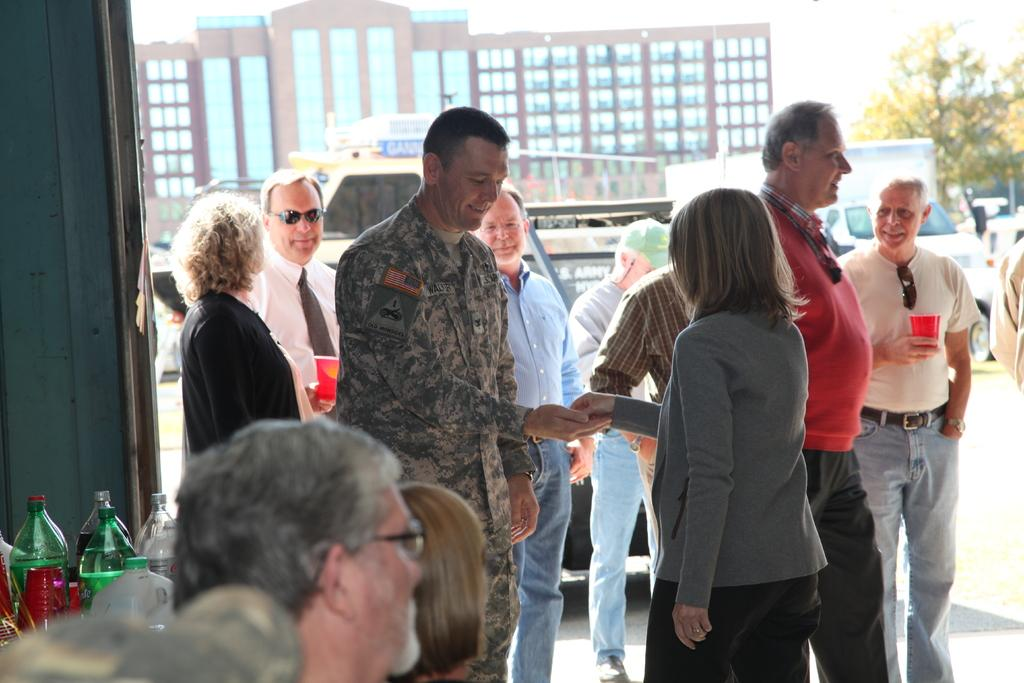How many people are present in the image? There are many people in the image. Can you describe the person holding a red cup? The person holding a red cup is on the right side of the image. What can be seen in the background of the image? There is a building and a tree in the background. What else can be seen on the left side of the image? There are some bottles on the left side of the image. What is the combing rate of the person holding the red cup? There is no mention of a comb or any combing activity in the image, so it is not possible to determine a combing rate. 